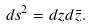<formula> <loc_0><loc_0><loc_500><loc_500>d s ^ { 2 } = d z d \bar { z } .</formula> 